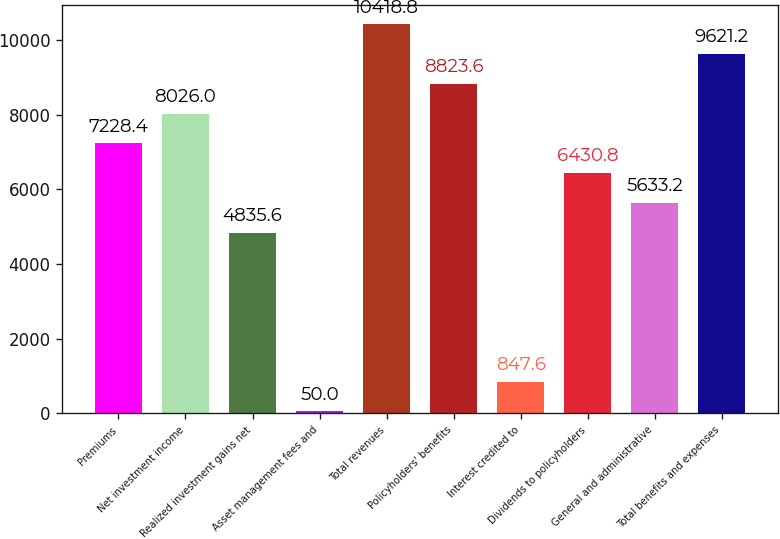<chart> <loc_0><loc_0><loc_500><loc_500><bar_chart><fcel>Premiums<fcel>Net investment income<fcel>Realized investment gains net<fcel>Asset management fees and<fcel>Total revenues<fcel>Policyholders' benefits<fcel>Interest credited to<fcel>Dividends to policyholders<fcel>General and administrative<fcel>Total benefits and expenses<nl><fcel>7228.4<fcel>8026<fcel>4835.6<fcel>50<fcel>10418.8<fcel>8823.6<fcel>847.6<fcel>6430.8<fcel>5633.2<fcel>9621.2<nl></chart> 